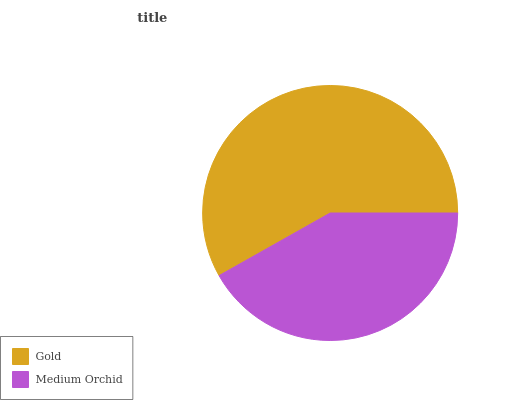Is Medium Orchid the minimum?
Answer yes or no. Yes. Is Gold the maximum?
Answer yes or no. Yes. Is Medium Orchid the maximum?
Answer yes or no. No. Is Gold greater than Medium Orchid?
Answer yes or no. Yes. Is Medium Orchid less than Gold?
Answer yes or no. Yes. Is Medium Orchid greater than Gold?
Answer yes or no. No. Is Gold less than Medium Orchid?
Answer yes or no. No. Is Gold the high median?
Answer yes or no. Yes. Is Medium Orchid the low median?
Answer yes or no. Yes. Is Medium Orchid the high median?
Answer yes or no. No. Is Gold the low median?
Answer yes or no. No. 